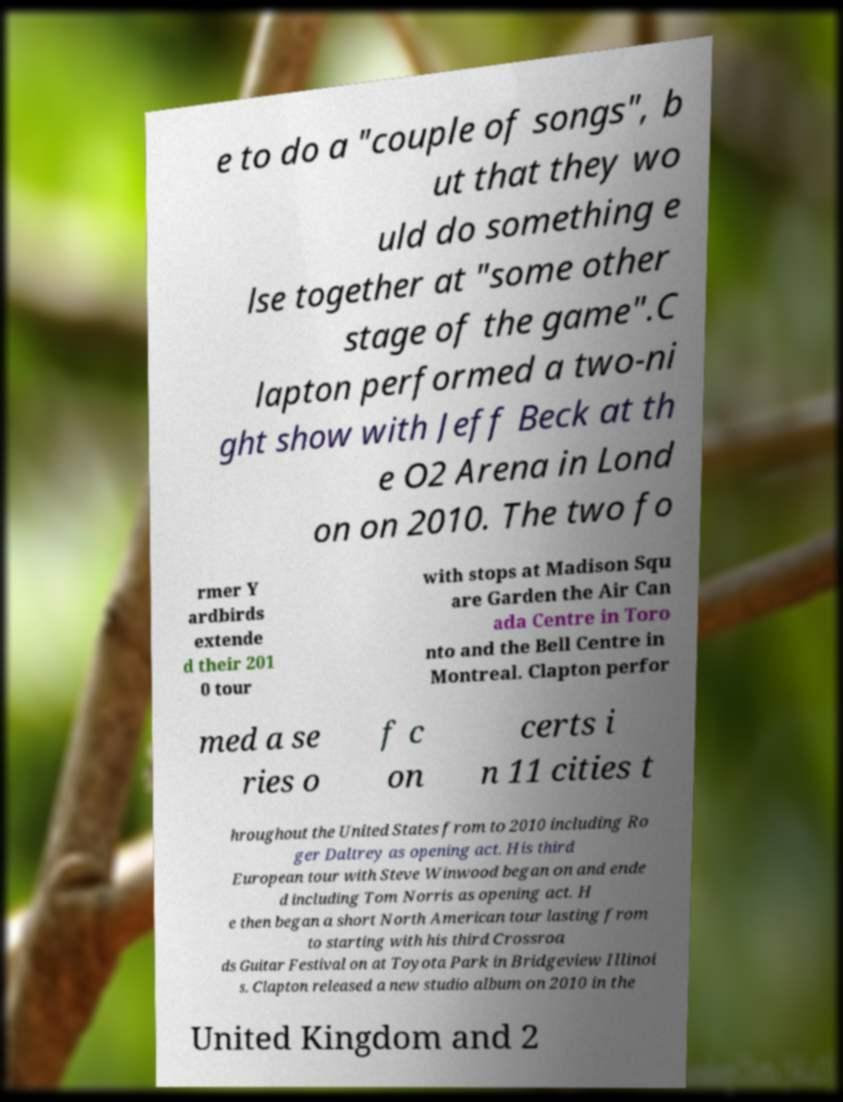There's text embedded in this image that I need extracted. Can you transcribe it verbatim? e to do a "couple of songs", b ut that they wo uld do something e lse together at "some other stage of the game".C lapton performed a two-ni ght show with Jeff Beck at th e O2 Arena in Lond on on 2010. The two fo rmer Y ardbirds extende d their 201 0 tour with stops at Madison Squ are Garden the Air Can ada Centre in Toro nto and the Bell Centre in Montreal. Clapton perfor med a se ries o f c on certs i n 11 cities t hroughout the United States from to 2010 including Ro ger Daltrey as opening act. His third European tour with Steve Winwood began on and ende d including Tom Norris as opening act. H e then began a short North American tour lasting from to starting with his third Crossroa ds Guitar Festival on at Toyota Park in Bridgeview Illinoi s. Clapton released a new studio album on 2010 in the United Kingdom and 2 